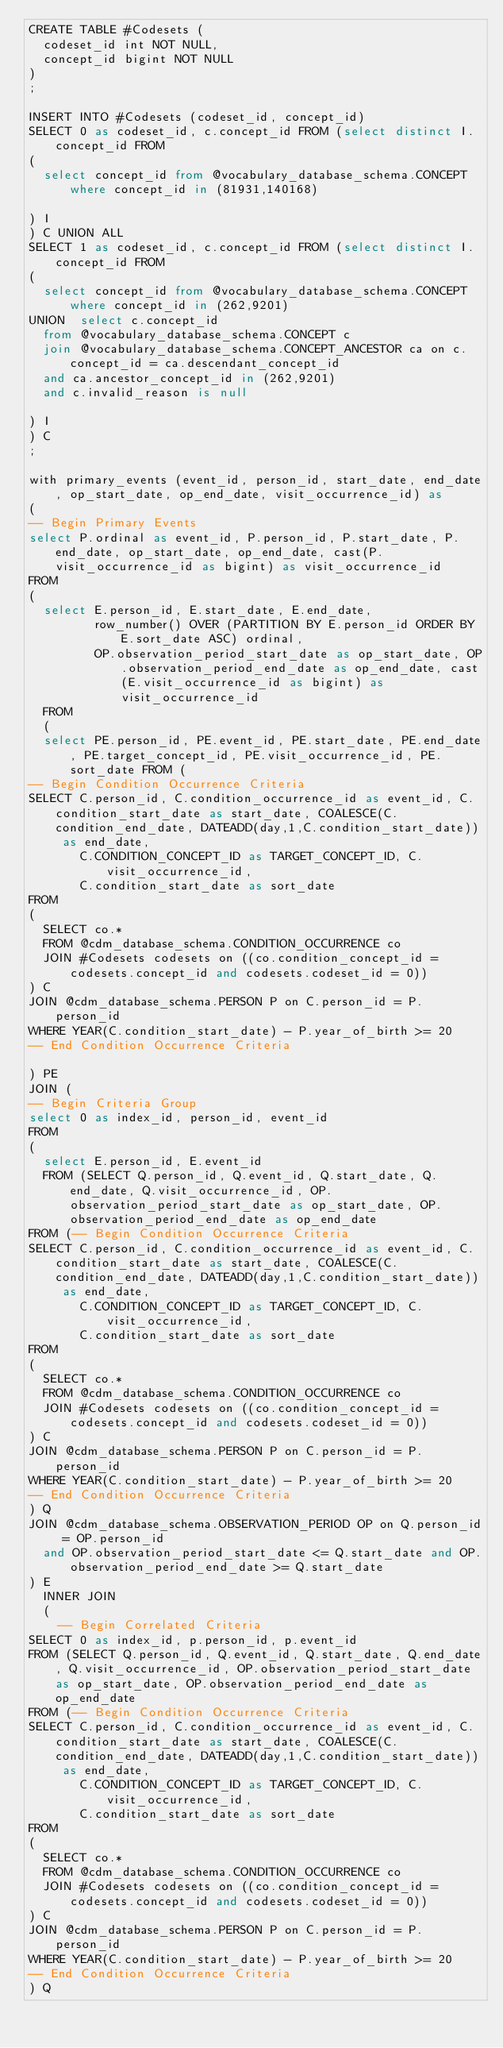Convert code to text. <code><loc_0><loc_0><loc_500><loc_500><_SQL_>CREATE TABLE #Codesets (
  codeset_id int NOT NULL,
  concept_id bigint NOT NULL
)
;

INSERT INTO #Codesets (codeset_id, concept_id)
SELECT 0 as codeset_id, c.concept_id FROM (select distinct I.concept_id FROM
( 
  select concept_id from @vocabulary_database_schema.CONCEPT where concept_id in (81931,140168)

) I
) C UNION ALL 
SELECT 1 as codeset_id, c.concept_id FROM (select distinct I.concept_id FROM
( 
  select concept_id from @vocabulary_database_schema.CONCEPT where concept_id in (262,9201)
UNION  select c.concept_id
  from @vocabulary_database_schema.CONCEPT c
  join @vocabulary_database_schema.CONCEPT_ANCESTOR ca on c.concept_id = ca.descendant_concept_id
  and ca.ancestor_concept_id in (262,9201)
  and c.invalid_reason is null

) I
) C
;

with primary_events (event_id, person_id, start_date, end_date, op_start_date, op_end_date, visit_occurrence_id) as
(
-- Begin Primary Events
select P.ordinal as event_id, P.person_id, P.start_date, P.end_date, op_start_date, op_end_date, cast(P.visit_occurrence_id as bigint) as visit_occurrence_id
FROM
(
  select E.person_id, E.start_date, E.end_date,
         row_number() OVER (PARTITION BY E.person_id ORDER BY E.sort_date ASC) ordinal,
         OP.observation_period_start_date as op_start_date, OP.observation_period_end_date as op_end_date, cast(E.visit_occurrence_id as bigint) as visit_occurrence_id
  FROM 
  (
  select PE.person_id, PE.event_id, PE.start_date, PE.end_date, PE.target_concept_id, PE.visit_occurrence_id, PE.sort_date FROM (
-- Begin Condition Occurrence Criteria
SELECT C.person_id, C.condition_occurrence_id as event_id, C.condition_start_date as start_date, COALESCE(C.condition_end_date, DATEADD(day,1,C.condition_start_date)) as end_date,
       C.CONDITION_CONCEPT_ID as TARGET_CONCEPT_ID, C.visit_occurrence_id,
       C.condition_start_date as sort_date
FROM 
(
  SELECT co.* 
  FROM @cdm_database_schema.CONDITION_OCCURRENCE co
  JOIN #Codesets codesets on ((co.condition_concept_id = codesets.concept_id and codesets.codeset_id = 0))
) C
JOIN @cdm_database_schema.PERSON P on C.person_id = P.person_id
WHERE YEAR(C.condition_start_date) - P.year_of_birth >= 20
-- End Condition Occurrence Criteria

) PE
JOIN (
-- Begin Criteria Group
select 0 as index_id, person_id, event_id
FROM
(
  select E.person_id, E.event_id 
  FROM (SELECT Q.person_id, Q.event_id, Q.start_date, Q.end_date, Q.visit_occurrence_id, OP.observation_period_start_date as op_start_date, OP.observation_period_end_date as op_end_date
FROM (-- Begin Condition Occurrence Criteria
SELECT C.person_id, C.condition_occurrence_id as event_id, C.condition_start_date as start_date, COALESCE(C.condition_end_date, DATEADD(day,1,C.condition_start_date)) as end_date,
       C.CONDITION_CONCEPT_ID as TARGET_CONCEPT_ID, C.visit_occurrence_id,
       C.condition_start_date as sort_date
FROM 
(
  SELECT co.* 
  FROM @cdm_database_schema.CONDITION_OCCURRENCE co
  JOIN #Codesets codesets on ((co.condition_concept_id = codesets.concept_id and codesets.codeset_id = 0))
) C
JOIN @cdm_database_schema.PERSON P on C.person_id = P.person_id
WHERE YEAR(C.condition_start_date) - P.year_of_birth >= 20
-- End Condition Occurrence Criteria
) Q
JOIN @cdm_database_schema.OBSERVATION_PERIOD OP on Q.person_id = OP.person_id 
  and OP.observation_period_start_date <= Q.start_date and OP.observation_period_end_date >= Q.start_date
) E
  INNER JOIN
  (
    -- Begin Correlated Criteria
SELECT 0 as index_id, p.person_id, p.event_id
FROM (SELECT Q.person_id, Q.event_id, Q.start_date, Q.end_date, Q.visit_occurrence_id, OP.observation_period_start_date as op_start_date, OP.observation_period_end_date as op_end_date
FROM (-- Begin Condition Occurrence Criteria
SELECT C.person_id, C.condition_occurrence_id as event_id, C.condition_start_date as start_date, COALESCE(C.condition_end_date, DATEADD(day,1,C.condition_start_date)) as end_date,
       C.CONDITION_CONCEPT_ID as TARGET_CONCEPT_ID, C.visit_occurrence_id,
       C.condition_start_date as sort_date
FROM 
(
  SELECT co.* 
  FROM @cdm_database_schema.CONDITION_OCCURRENCE co
  JOIN #Codesets codesets on ((co.condition_concept_id = codesets.concept_id and codesets.codeset_id = 0))
) C
JOIN @cdm_database_schema.PERSON P on C.person_id = P.person_id
WHERE YEAR(C.condition_start_date) - P.year_of_birth >= 20
-- End Condition Occurrence Criteria
) Q</code> 